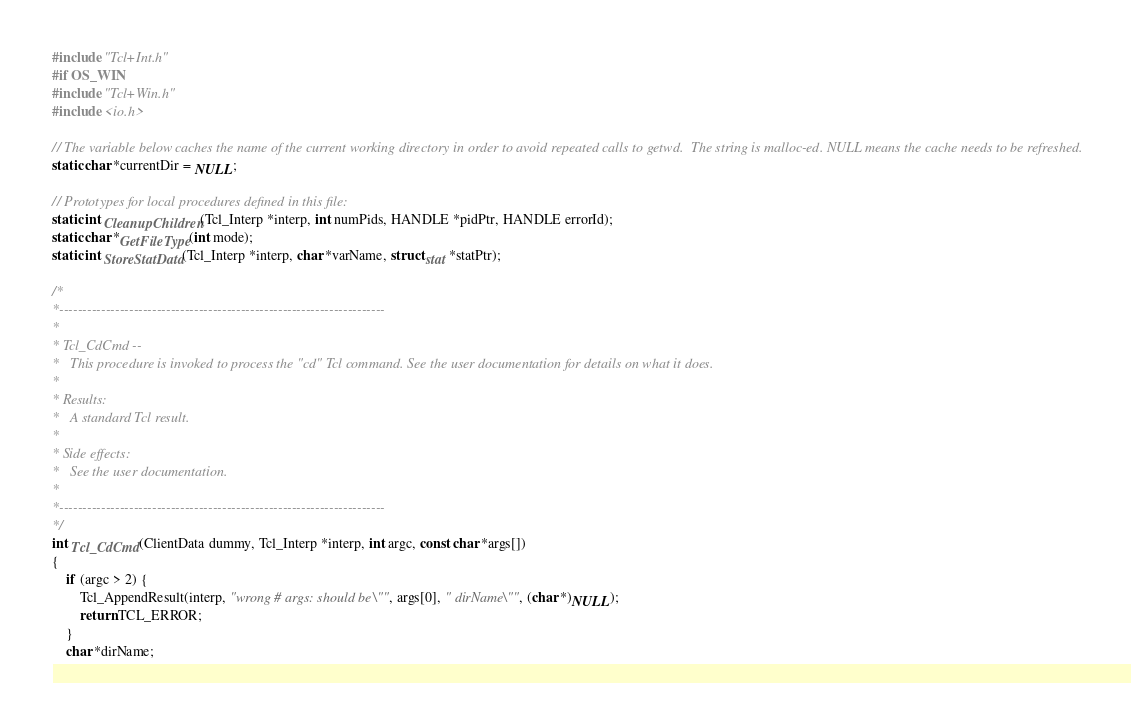Convert code to text. <code><loc_0><loc_0><loc_500><loc_500><_Cuda_>#include "Tcl+Int.h"
#if OS_WIN
#include "Tcl+Win.h"
#include <io.h>

// The variable below caches the name of the current working directory in order to avoid repeated calls to getwd.  The string is malloc-ed. NULL means the cache needs to be refreshed.
static char *currentDir = NULL;

// Prototypes for local procedures defined in this file:
static int CleanupChildren(Tcl_Interp *interp, int numPids, HANDLE *pidPtr, HANDLE errorId);
static char *GetFileType(int mode);
static int StoreStatData(Tcl_Interp *interp, char *varName, struct stat *statPtr);

/*
*----------------------------------------------------------------------
*
* Tcl_CdCmd --
*	This procedure is invoked to process the "cd" Tcl command. See the user documentation for details on what it does.
*
* Results:
*	A standard Tcl result.
*
* Side effects:
*	See the user documentation.
*
*----------------------------------------------------------------------
*/
int Tcl_CdCmd(ClientData dummy, Tcl_Interp *interp, int argc, const char *args[])
{
	if (argc > 2) {
		Tcl_AppendResult(interp, "wrong # args: should be \"", args[0], " dirName\"", (char *)NULL);
		return TCL_ERROR;
	}
	char *dirName;</code> 